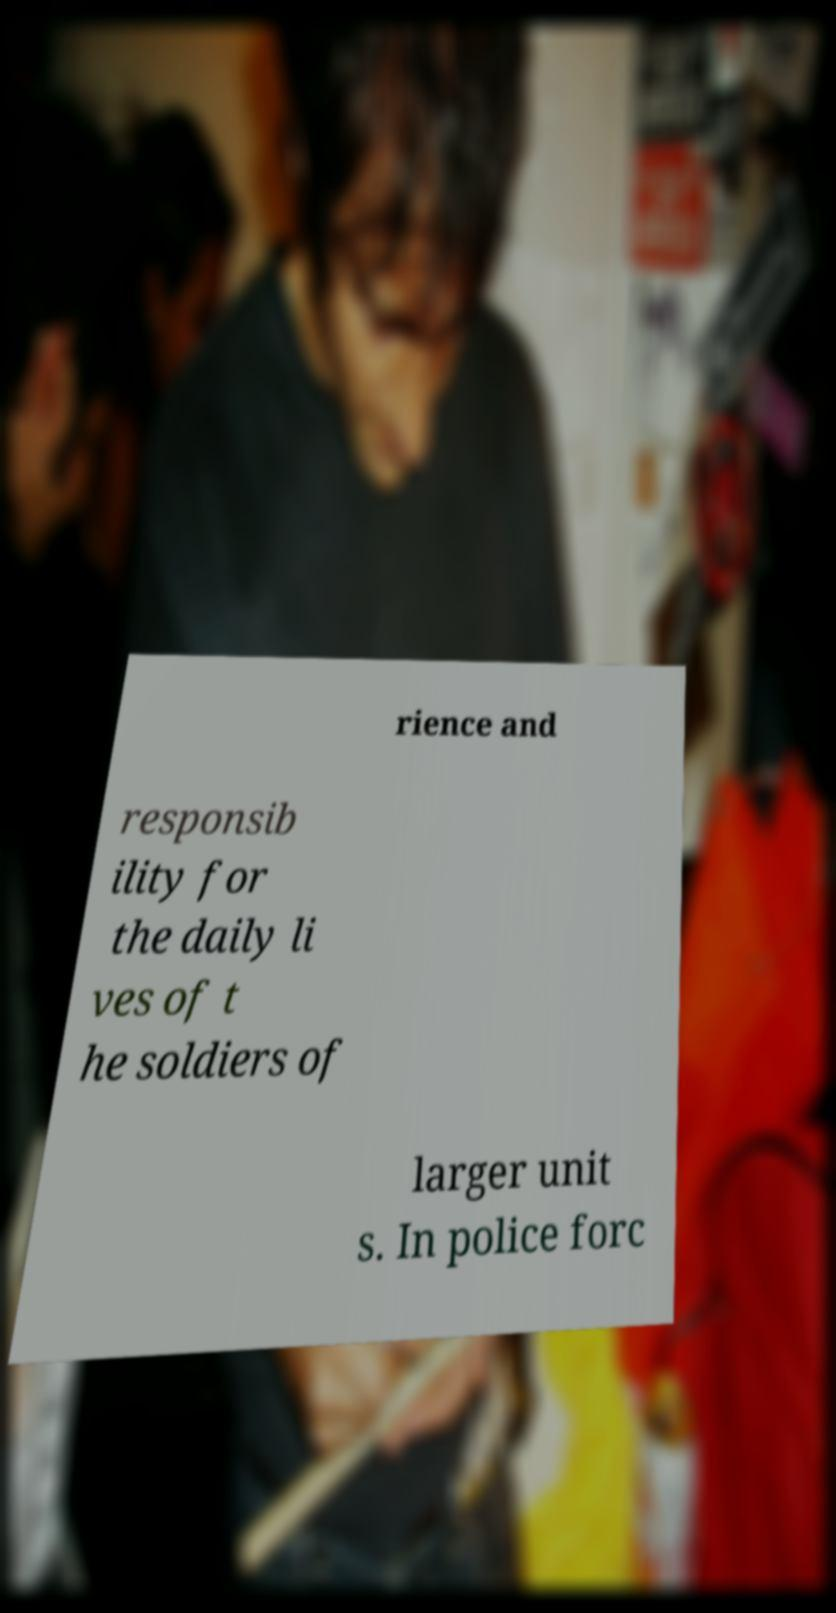There's text embedded in this image that I need extracted. Can you transcribe it verbatim? rience and responsib ility for the daily li ves of t he soldiers of larger unit s. In police forc 